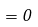Convert formula to latex. <formula><loc_0><loc_0><loc_500><loc_500>= 0</formula> 